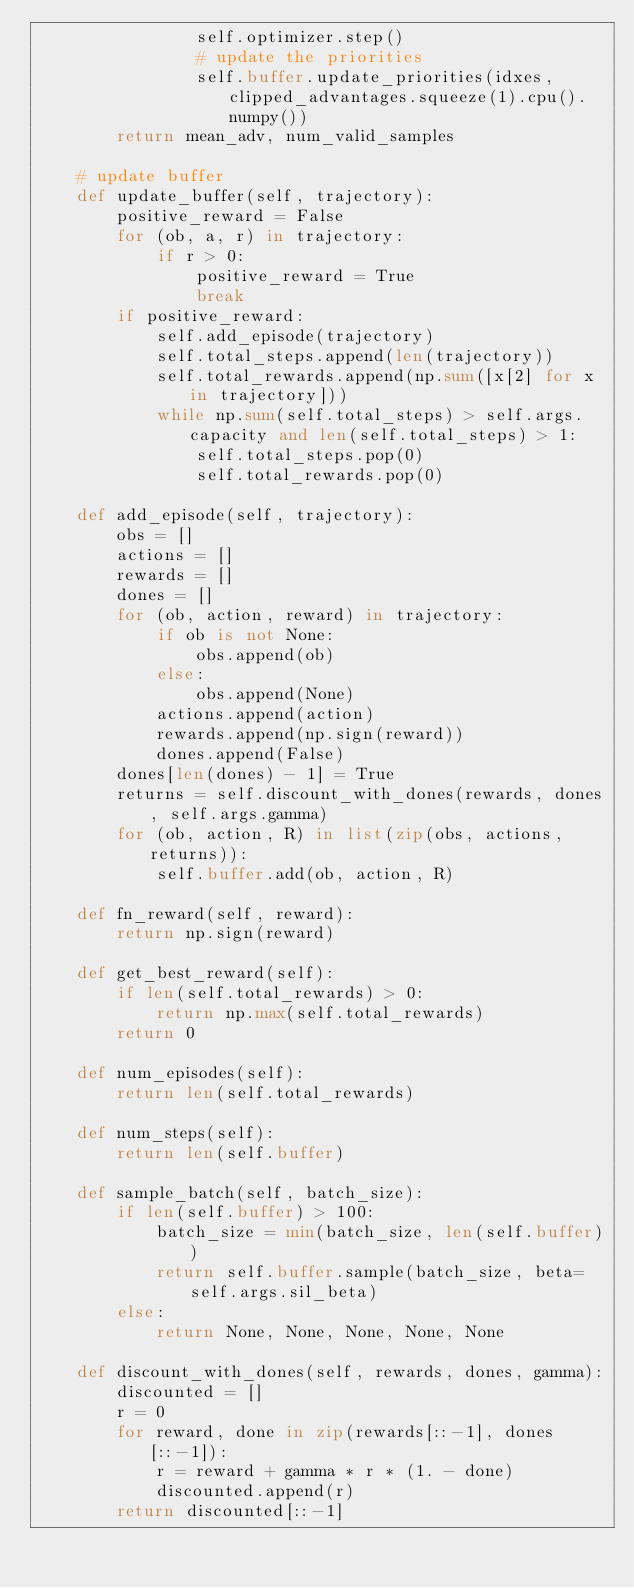Convert code to text. <code><loc_0><loc_0><loc_500><loc_500><_Python_>                self.optimizer.step()
                # update the priorities
                self.buffer.update_priorities(idxes, clipped_advantages.squeeze(1).cpu().numpy())
        return mean_adv, num_valid_samples
    
    # update buffer
    def update_buffer(self, trajectory):
        positive_reward = False
        for (ob, a, r) in trajectory:
            if r > 0:
                positive_reward = True
                break
        if positive_reward:
            self.add_episode(trajectory)
            self.total_steps.append(len(trajectory))
            self.total_rewards.append(np.sum([x[2] for x in trajectory]))
            while np.sum(self.total_steps) > self.args.capacity and len(self.total_steps) > 1:
                self.total_steps.pop(0)
                self.total_rewards.pop(0)

    def add_episode(self, trajectory):
        obs = []
        actions = []
        rewards = []
        dones = []
        for (ob, action, reward) in trajectory:
            if ob is not None:
                obs.append(ob)
            else:
                obs.append(None)
            actions.append(action)
            rewards.append(np.sign(reward))
            dones.append(False)
        dones[len(dones) - 1] = True
        returns = self.discount_with_dones(rewards, dones, self.args.gamma)
        for (ob, action, R) in list(zip(obs, actions, returns)):
            self.buffer.add(ob, action, R)

    def fn_reward(self, reward):
        return np.sign(reward)

    def get_best_reward(self):
        if len(self.total_rewards) > 0:
            return np.max(self.total_rewards)
        return 0
    
    def num_episodes(self):
        return len(self.total_rewards)

    def num_steps(self):
        return len(self.buffer)

    def sample_batch(self, batch_size):
        if len(self.buffer) > 100:
            batch_size = min(batch_size, len(self.buffer))
            return self.buffer.sample(batch_size, beta=self.args.sil_beta)
        else:
            return None, None, None, None, None

    def discount_with_dones(self, rewards, dones, gamma):
        discounted = []
        r = 0
        for reward, done in zip(rewards[::-1], dones[::-1]):
            r = reward + gamma * r * (1. - done)
            discounted.append(r)
        return discounted[::-1]
</code> 